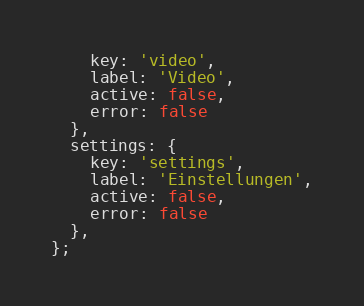<code> <loc_0><loc_0><loc_500><loc_500><_JavaScript_>    key: 'video',
    label: 'Video',
    active: false,
    error: false
  },
  settings: {
    key: 'settings',
    label: 'Einstellungen',
    active: false,
    error: false
  },
};</code> 